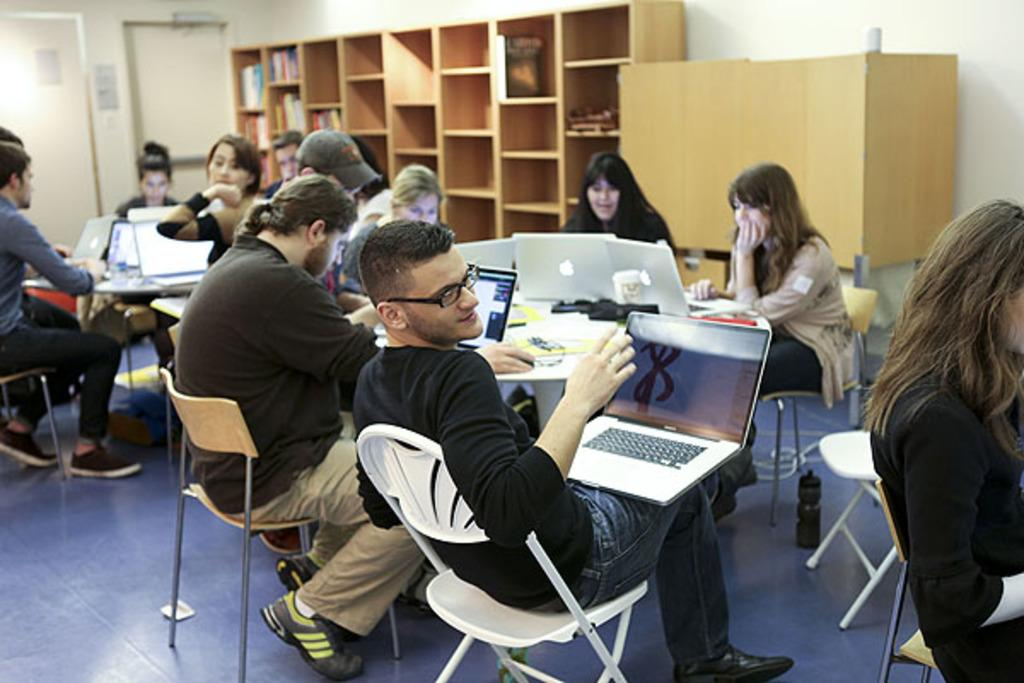How many people are in the image? There is a group of people in the image. What are the people doing in the image? The people are sitting in front of a table. What objects can be seen on the table? There are laptops on the table. What is located at the back of the image? There is a cupboard at the back of the image. What is inside the cupboard? There are books inside the cupboard. How many babies are crawling on the table in the image? There are no babies present in the image; it features a group of people sitting in front of a table with laptops. What type of kittens can be seen playing with the books inside the cupboard? There are no kittens present in the image; it features a cupboard with books inside. 